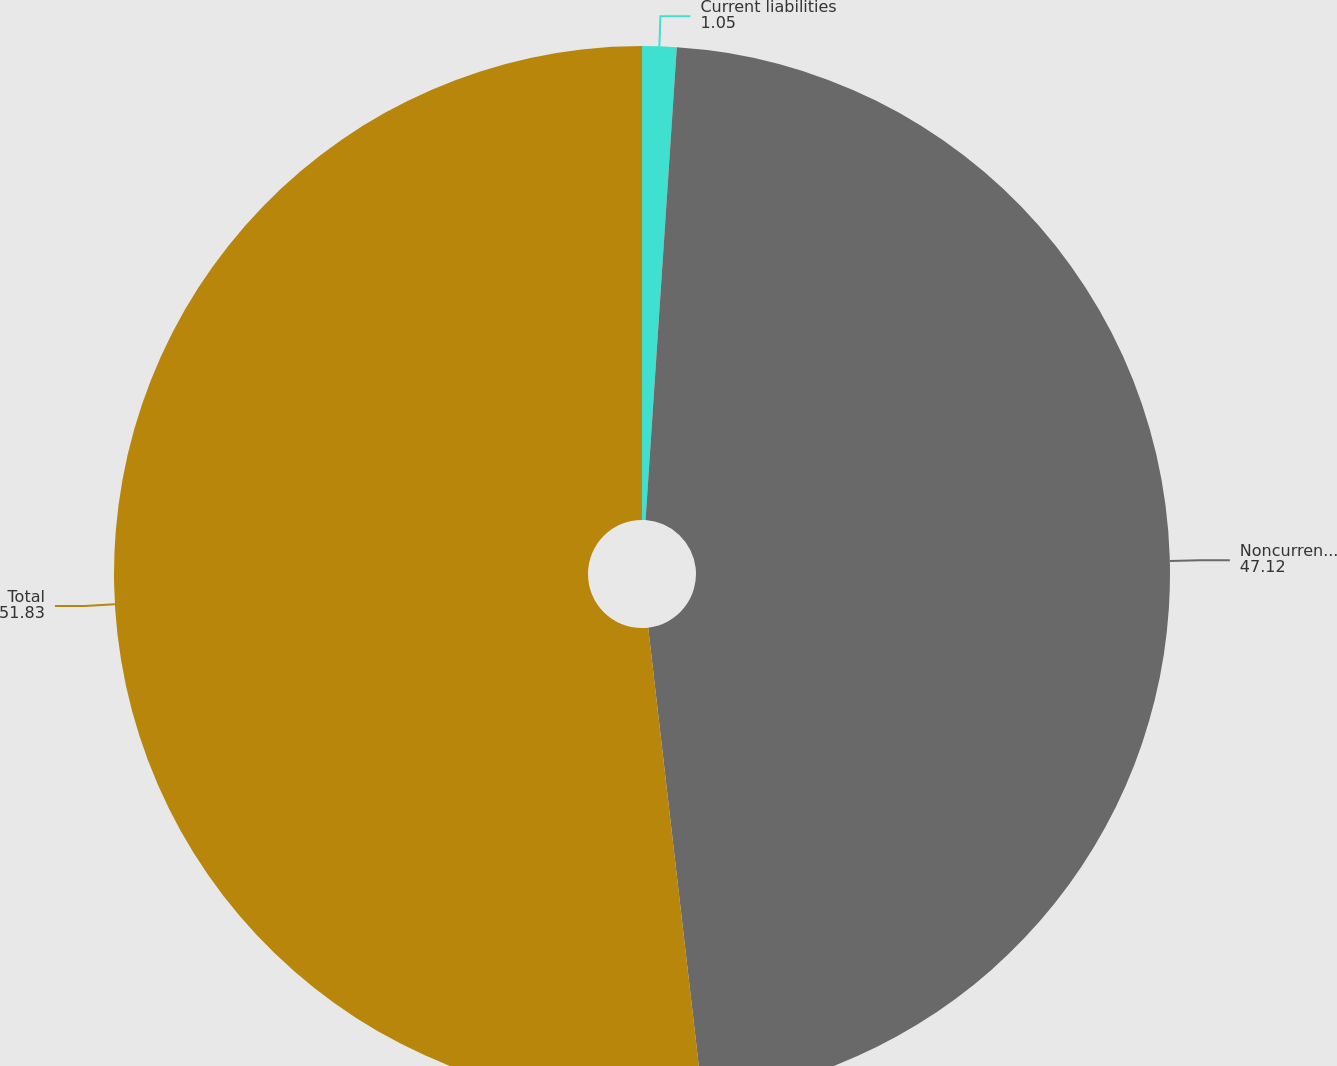<chart> <loc_0><loc_0><loc_500><loc_500><pie_chart><fcel>Current liabilities<fcel>Noncurrent liabilities<fcel>Total<nl><fcel>1.05%<fcel>47.12%<fcel>51.83%<nl></chart> 